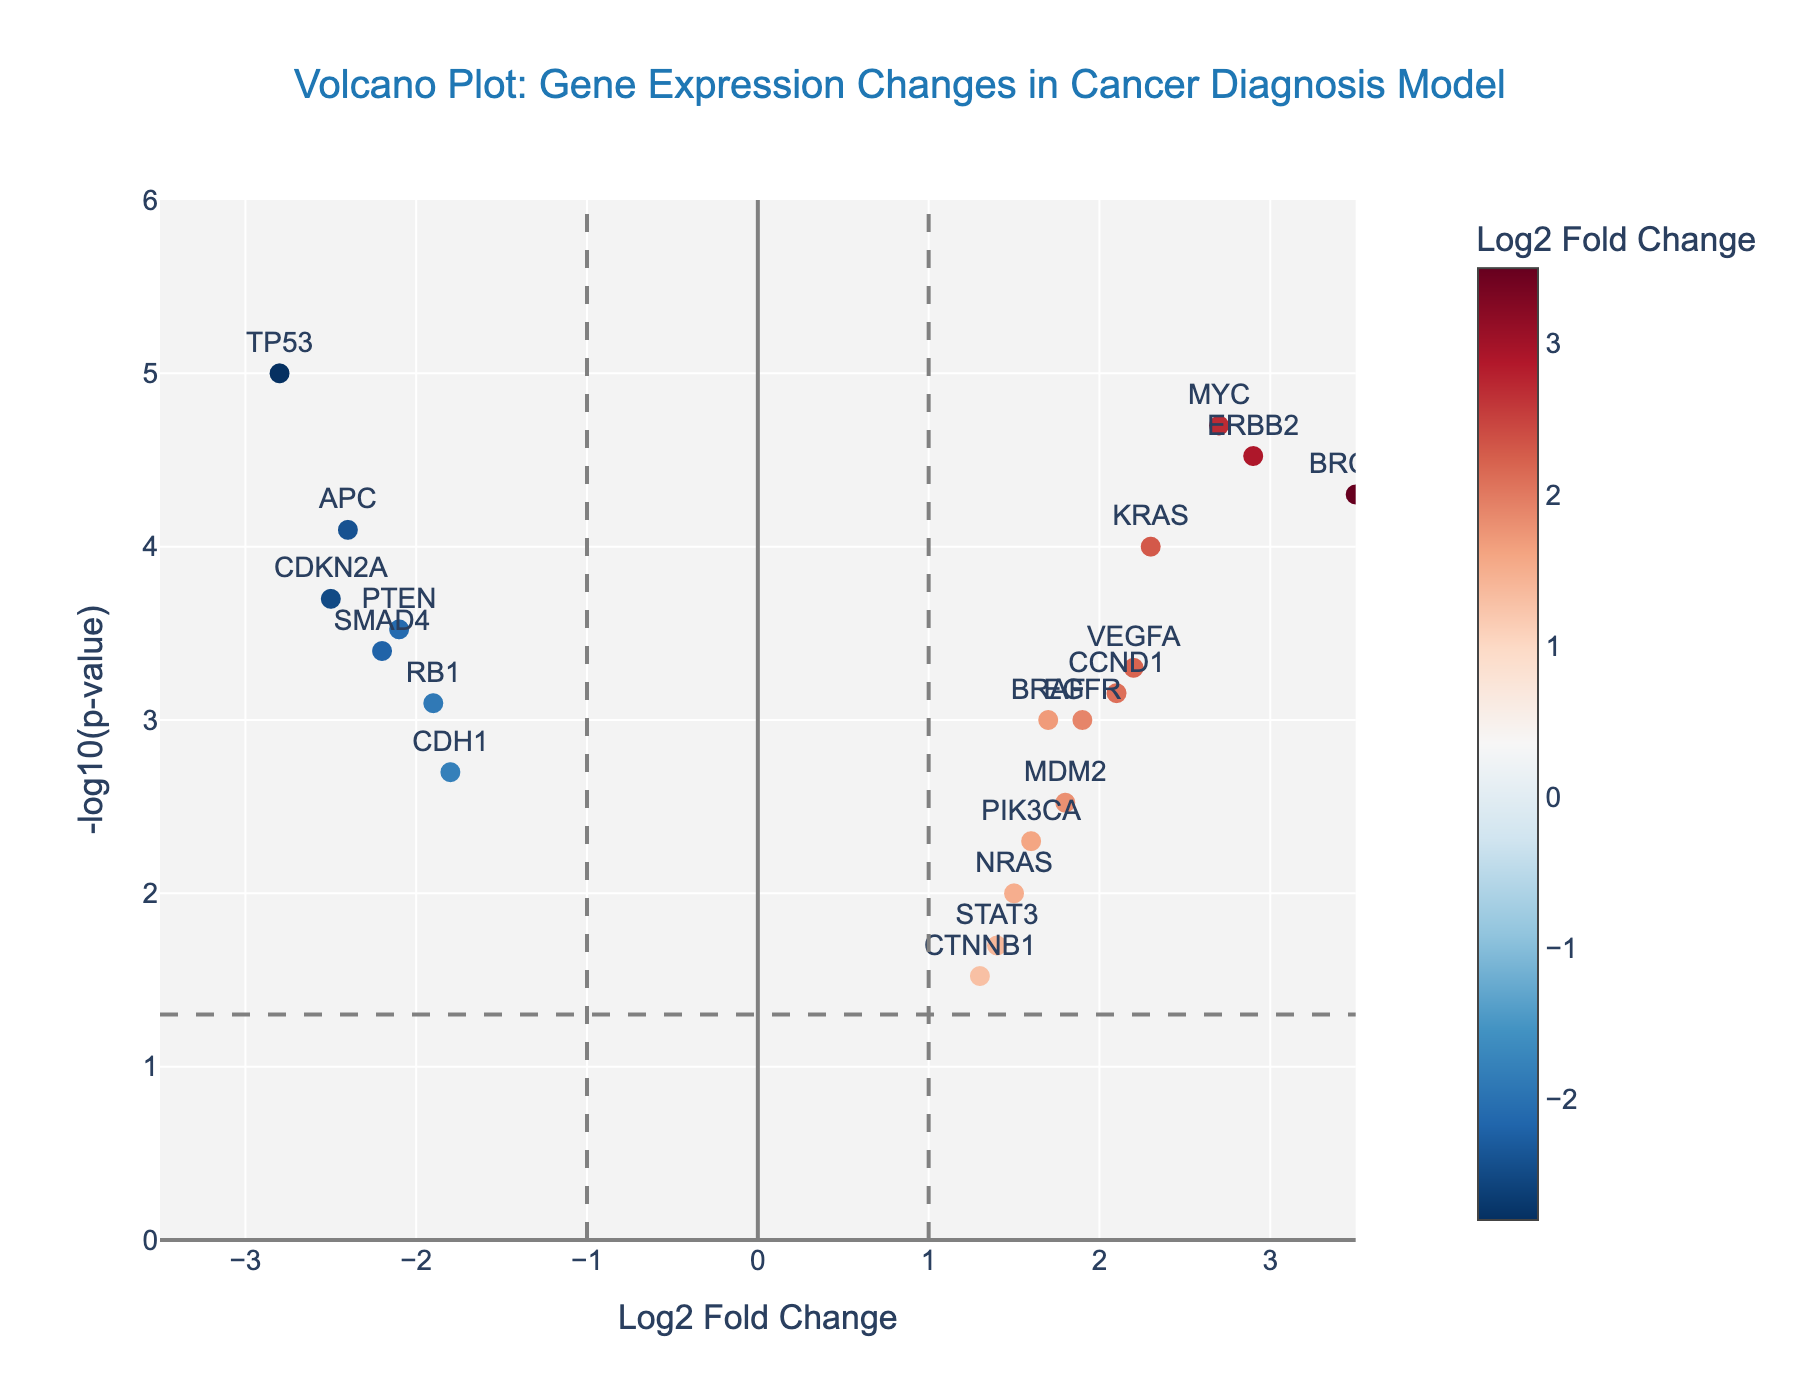What is the title of the volcano plot? The title is displayed at the top center of the plot in larger font for easier identification.
Answer: Volcano Plot: Gene Expression Changes in Cancer Diagnosis Model Which gene has the highest log2 fold change? The gene with the highest log2 fold change will be the point furthest to the right on the x-axis.
Answer: BRCA1 What is the log2 fold change and p-value of gene TP53? Locate TP53 in the hover text or find its point in the plot, then read off its log2 fold change on the x-axis and its p-value (inverted logarithmic form) on the y-axis.
Answer: Log2FC: -2.8, p-value: 0.00001 How many genes have a log2 fold change greater than 2? Count the points to the right of the line x=2. Genes BRCA1, MYC, and ERBB2 all have log2 fold changes greater than 2.
Answer: 3 Which gene has the most significant p-value? The gene with the most significant p-value will be the point highest on the y-axis, as this corresponds to -log10(p-value).
Answer: TP53 How many genes have a log2 fold change less than -2? Count the points to the left of the line x=-2. Genes TP53, PTEN, APC, and CDKN2A all have log2 fold changes less than -2.
Answer: 4 Which gene has a log2 fold change closest to zero but still significant? Compare the genes with p-values less than 0.05 (above the horizontal dashed line) and find the one closest to the zero log2 fold change line.
Answer: CTNNB1 What are the vertical and horizontal dashed lines representing? The vertical dashed lines at x=-1 and x=1 represent log2 fold changes of -1 and 1 respectively, while the horizontal dashed line represents a p-value threshold of 0.05 (-log10(p-value) = 1.3).
Answer: FC thresholds and p-value threshold Compare the log2 fold changes of KRAS and CDKN2A. Find the log2 fold changes of these genes on the x-axis: KRAS at 2.3 and CDKN2A at -2.5, and then determine their relationship.
Answer: KRAS (2.3) is higher than CDKN2A (-2.5) Is the gene MYC up-regulated or down-regulated and by how much? Up-regulated genes have positive log2 fold changes, and the distance from zero on the x-axis gives the amount. MYC is to the right of the zero-line.
Answer: Up-regulated by 2.7 